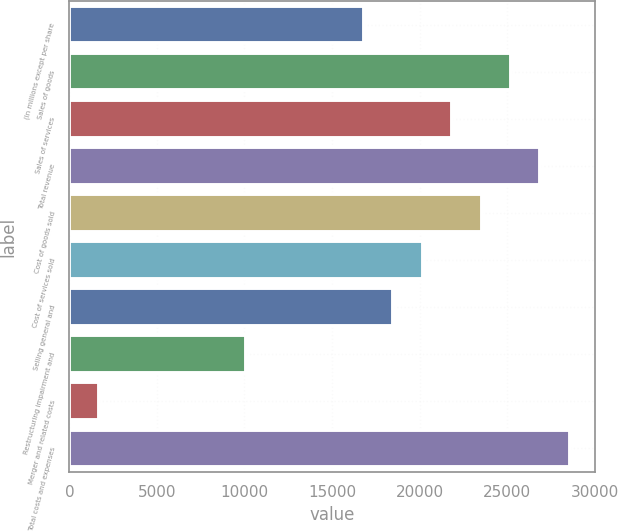Convert chart to OTSL. <chart><loc_0><loc_0><loc_500><loc_500><bar_chart><fcel>(In millions except per share<fcel>Sales of goods<fcel>Sales of services<fcel>Total revenue<fcel>Cost of goods sold<fcel>Cost of services sold<fcel>Selling general and<fcel>Restructuring impairment and<fcel>Merger and related costs<fcel>Total costs and expenses<nl><fcel>16826<fcel>25226.5<fcel>21866.3<fcel>26906.6<fcel>23546.4<fcel>20186.2<fcel>18506.1<fcel>10105.6<fcel>1705.1<fcel>28586.7<nl></chart> 